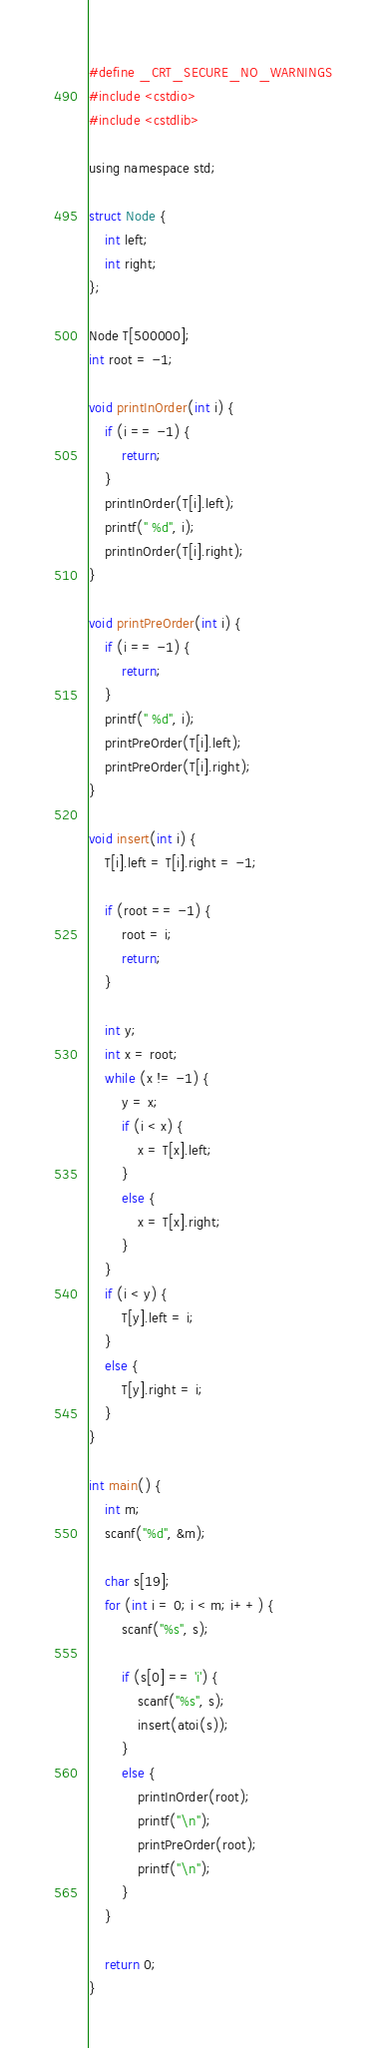<code> <loc_0><loc_0><loc_500><loc_500><_C_>#define _CRT_SECURE_NO_WARNINGS
#include <cstdio>
#include <cstdlib>
 
using namespace std;
 
struct Node {
    int left;
    int right;
};
 
Node T[500000];
int root = -1;
 
void printInOrder(int i) {
    if (i == -1) {
        return;
    }
    printInOrder(T[i].left);
    printf(" %d", i);
    printInOrder(T[i].right);
}
 
void printPreOrder(int i) {
    if (i == -1) {
        return;
    }
    printf(" %d", i);
    printPreOrder(T[i].left);
    printPreOrder(T[i].right);
}
 
void insert(int i) {
    T[i].left = T[i].right = -1;
 
    if (root == -1) {
        root = i;
        return;
    }
 
    int y;
    int x = root;
    while (x != -1) {
        y = x;
        if (i < x) {
            x = T[x].left;
        }
        else {
            x = T[x].right;
        }
    }
    if (i < y) {
        T[y].left = i;
    }
    else {
        T[y].right = i;
    }
}
 
int main() {
    int m;
    scanf("%d", &m);
 
    char s[19];
    for (int i = 0; i < m; i++) {
        scanf("%s", s);
 
        if (s[0] == 'i') {
            scanf("%s", s);
            insert(atoi(s));
        }
        else {
            printInOrder(root);
            printf("\n");
            printPreOrder(root);
            printf("\n");
        }
    }
 
    return 0;
}</code> 